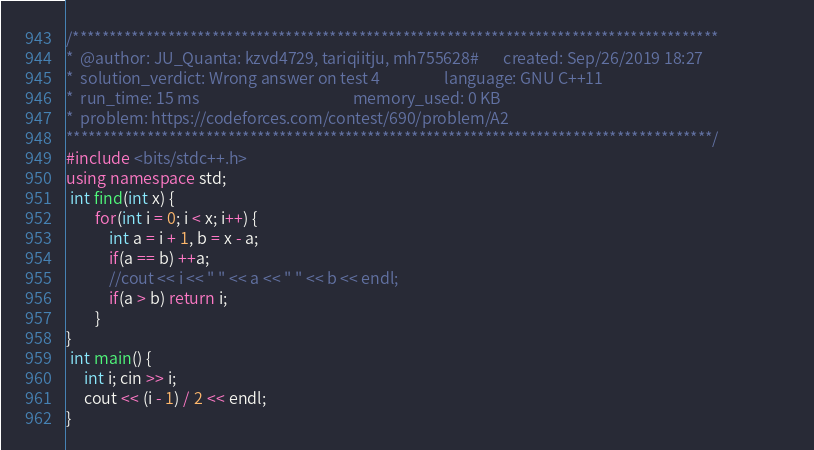Convert code to text. <code><loc_0><loc_0><loc_500><loc_500><_C++_>/****************************************************************************************
*  @author: JU_Quanta: kzvd4729, tariqiitju, mh755628#       created: Sep/26/2019 18:27                        
*  solution_verdict: Wrong answer on test 4                  language: GNU C++11                               
*  run_time: 15 ms                                           memory_used: 0 KB                                 
*  problem: https://codeforces.com/contest/690/problem/A2
****************************************************************************************/
#include <bits/stdc++.h>
using namespace std;
 int find(int x) {
        for(int i = 0; i < x; i++) {
            int a = i + 1, b = x - a;
            if(a == b) ++a;
            //cout << i << " " << a << " " << b << endl;
            if(a > b) return i;
        }
}
 int main() {
     int i; cin >> i;
     cout << (i - 1) / 2 << endl;
}</code> 